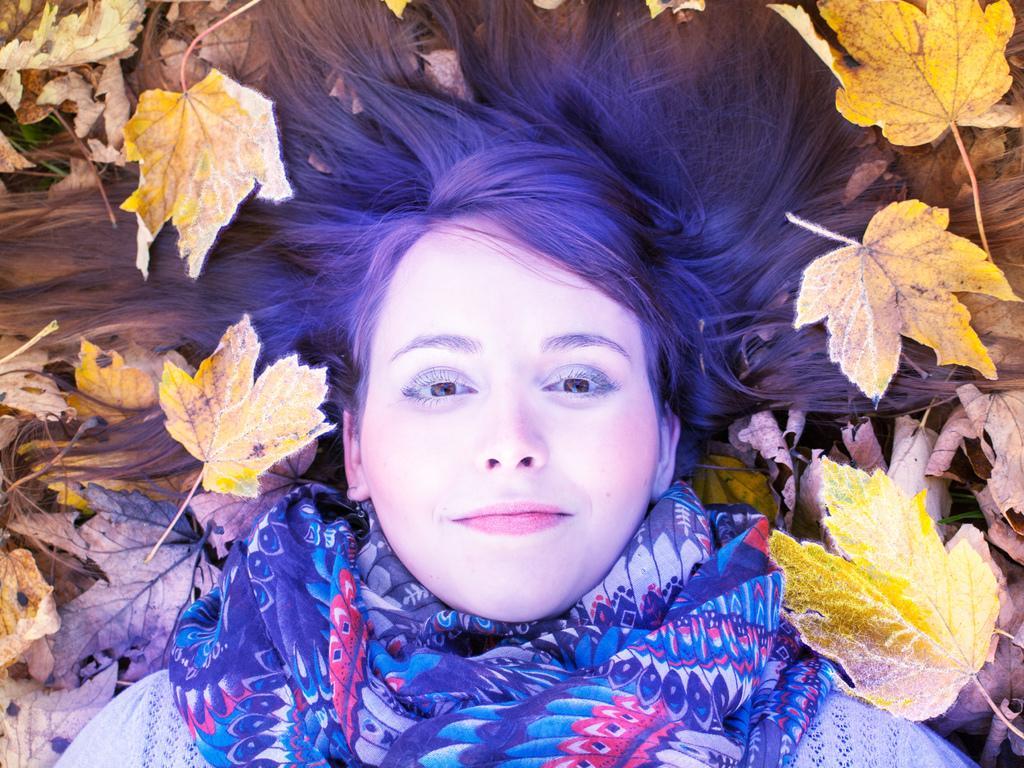Please provide a concise description of this image. In this image we can a woman lying on the ground. We can also see some dried leaves around her. 